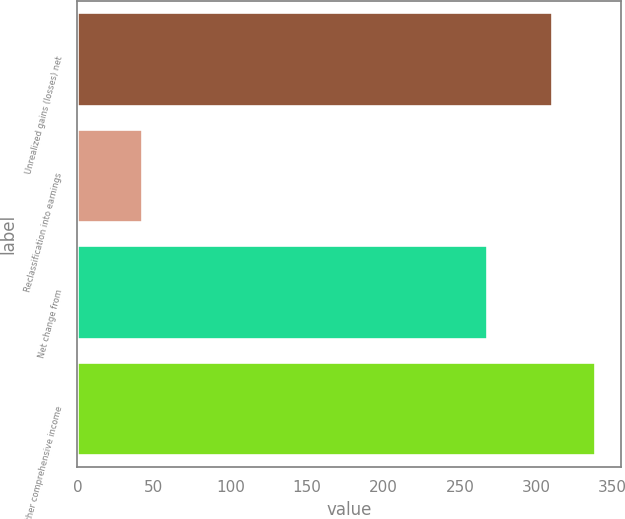<chart> <loc_0><loc_0><loc_500><loc_500><bar_chart><fcel>Unrealized gains (losses) net<fcel>Reclassification into earnings<fcel>Net change from<fcel>Other comprehensive income<nl><fcel>310<fcel>42<fcel>268<fcel>338.3<nl></chart> 